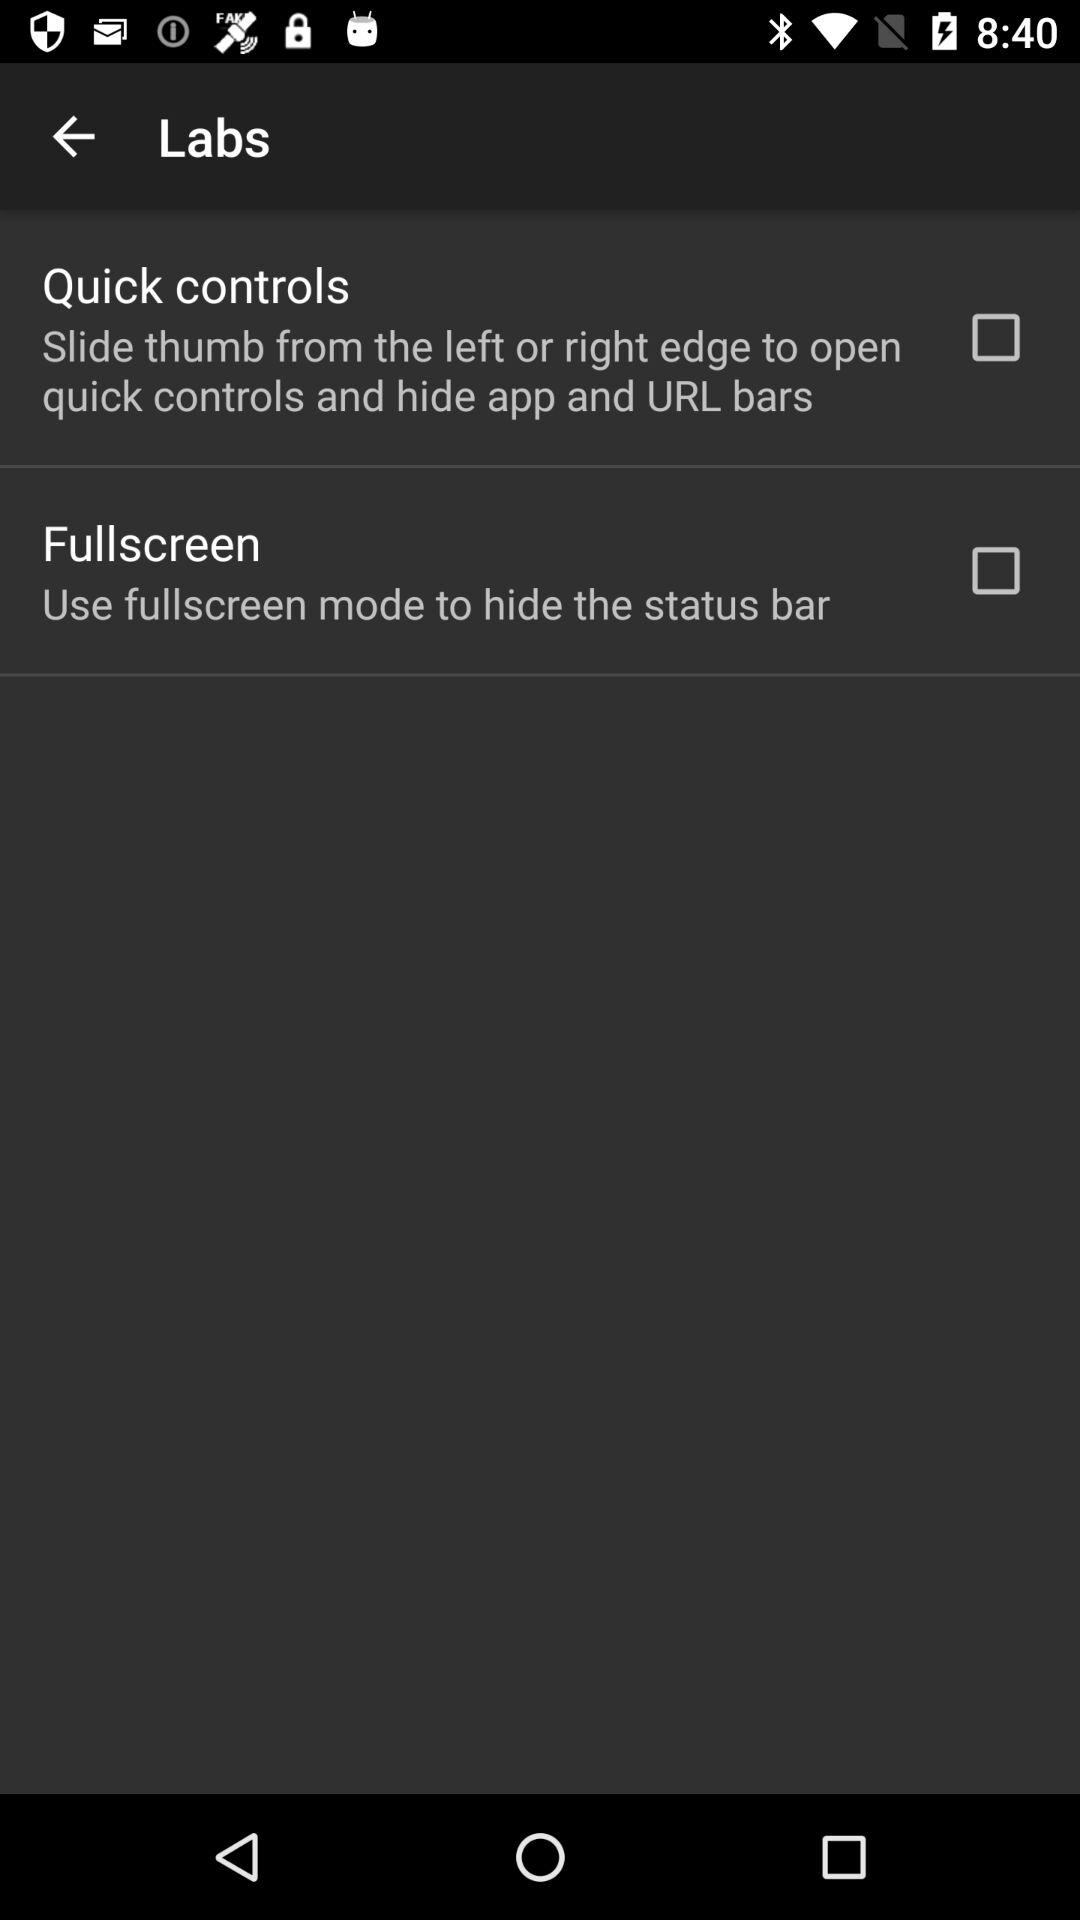How many labs options are there?
Answer the question using a single word or phrase. 2 